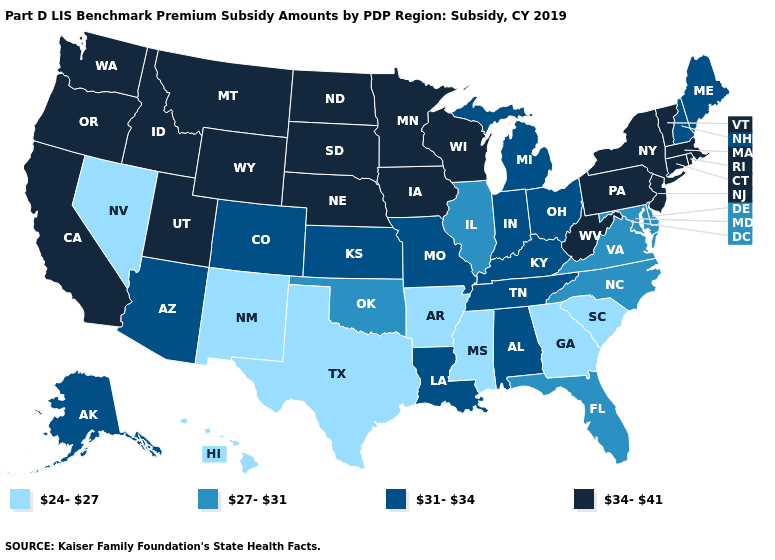Does the map have missing data?
Concise answer only. No. Does Montana have a lower value than Wyoming?
Answer briefly. No. What is the value of Rhode Island?
Quick response, please. 34-41. Which states have the highest value in the USA?
Concise answer only. California, Connecticut, Idaho, Iowa, Massachusetts, Minnesota, Montana, Nebraska, New Jersey, New York, North Dakota, Oregon, Pennsylvania, Rhode Island, South Dakota, Utah, Vermont, Washington, West Virginia, Wisconsin, Wyoming. Name the states that have a value in the range 24-27?
Concise answer only. Arkansas, Georgia, Hawaii, Mississippi, Nevada, New Mexico, South Carolina, Texas. Name the states that have a value in the range 24-27?
Write a very short answer. Arkansas, Georgia, Hawaii, Mississippi, Nevada, New Mexico, South Carolina, Texas. Which states have the lowest value in the USA?
Keep it brief. Arkansas, Georgia, Hawaii, Mississippi, Nevada, New Mexico, South Carolina, Texas. What is the value of Idaho?
Answer briefly. 34-41. Name the states that have a value in the range 34-41?
Give a very brief answer. California, Connecticut, Idaho, Iowa, Massachusetts, Minnesota, Montana, Nebraska, New Jersey, New York, North Dakota, Oregon, Pennsylvania, Rhode Island, South Dakota, Utah, Vermont, Washington, West Virginia, Wisconsin, Wyoming. Does South Carolina have the lowest value in the South?
Be succinct. Yes. What is the highest value in the USA?
Quick response, please. 34-41. Name the states that have a value in the range 31-34?
Answer briefly. Alabama, Alaska, Arizona, Colorado, Indiana, Kansas, Kentucky, Louisiana, Maine, Michigan, Missouri, New Hampshire, Ohio, Tennessee. Does Montana have the highest value in the West?
Quick response, please. Yes. What is the value of Arizona?
Be succinct. 31-34. 